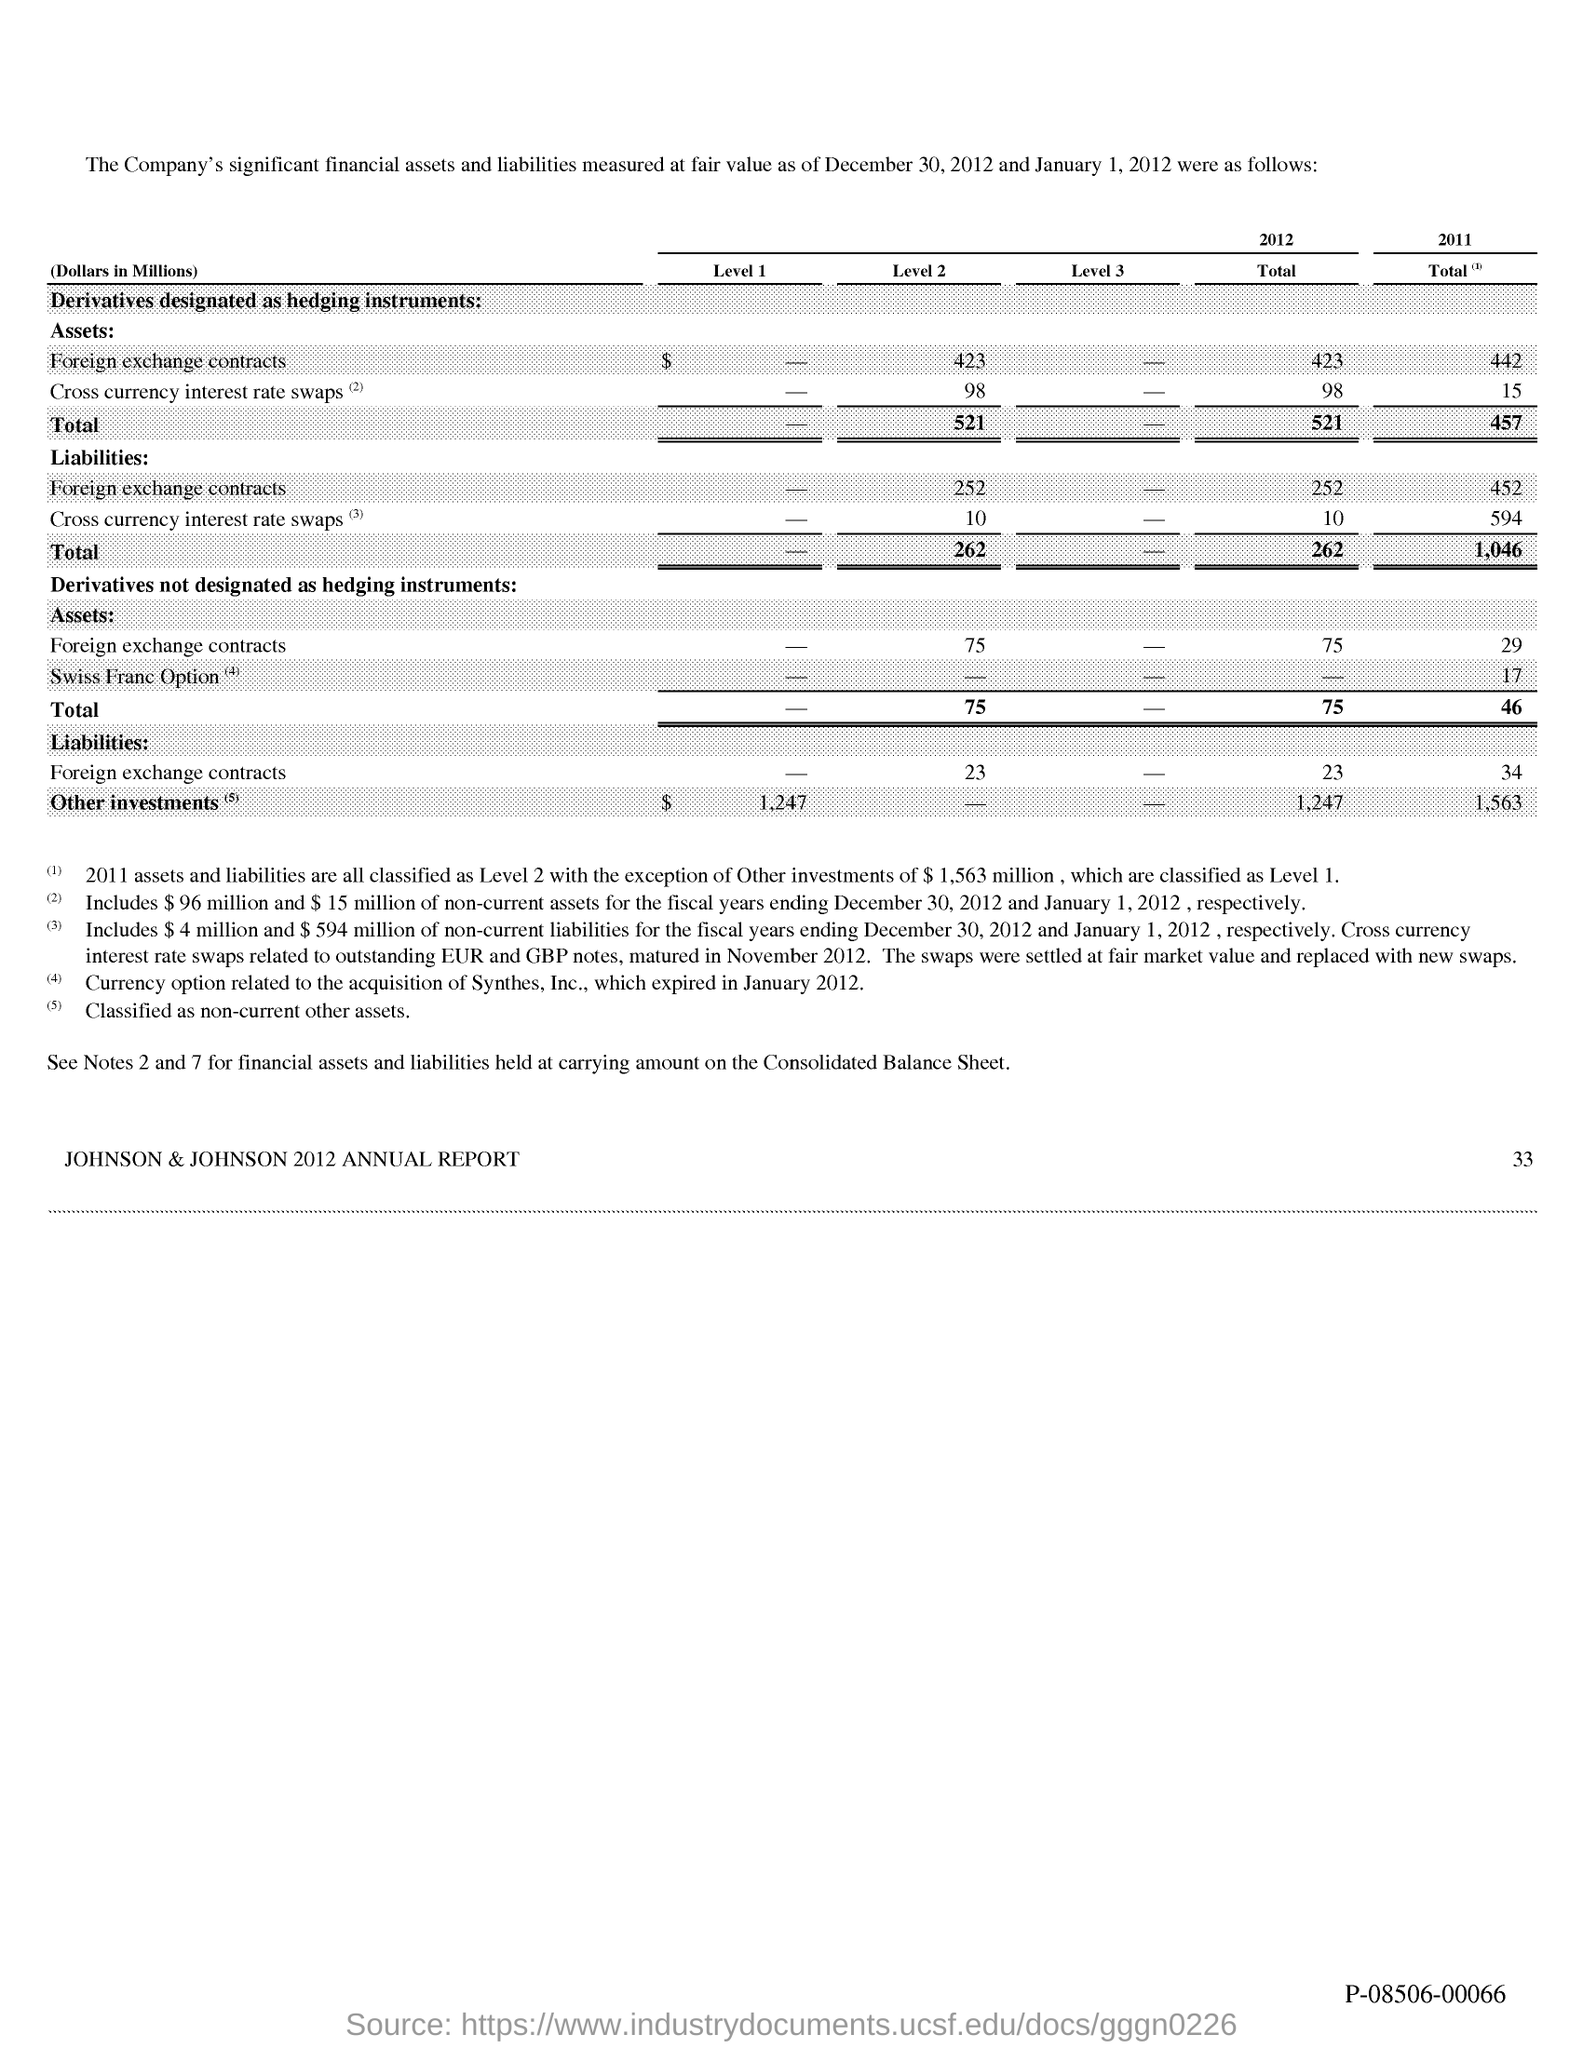What is the Cross currency interest rate swaps for Level 2 for Assets?
Offer a terse response. 98. What is the Total for Level 2 Liabilities?
Give a very brief answer. 262. What is the Total for 2011 Liabilities?
Your answer should be very brief. 1,046. What is the Total for 2012 Liabilities?
Offer a very short reply. 262. 